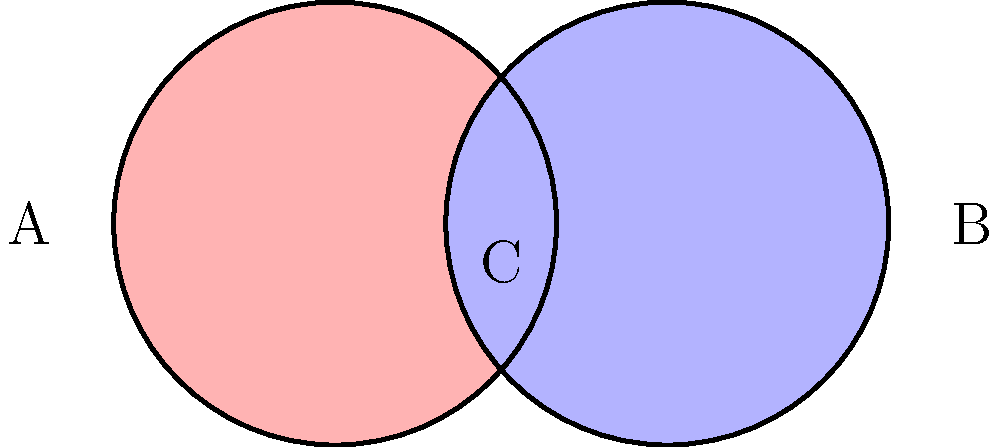In your latest artwork inspired by Juanita Lecaros's use of overlapping forms, you've created a Venn diagram-like composition using two intersecting circles of equal radius. If each circle has a radius of 5 meters, what is the area of the overlapping region (labeled C) in square meters? Round your answer to two decimal places. To find the area of the overlapping region, we need to follow these steps:

1) First, we need to calculate the area of a sector in one circle. The central angle of this sector can be found using the formula:

   $$\theta = 2 \arccos(\frac{d}{2r})$$

   where $d$ is the distance between the centers, and $r$ is the radius.

2) In this case, $d = r = 5$ meters, so:

   $$\theta = 2 \arccos(\frac{5}{2(5)}) = 2 \arccos(0.5) = 2(\frac{\pi}{3}) = \frac{2\pi}{3}$$ radians

3) The area of a sector is given by:

   $$A_{sector} = \frac{1}{2}r^2\theta$$

4) Substituting our values:

   $$A_{sector} = \frac{1}{2}(5^2)(\frac{2\pi}{3}) = \frac{25\pi}{3}$$ sq meters

5) The area of the triangle formed by the radius and chord is:

   $$A_{triangle} = \frac{1}{2}r^2\sin(\theta) = \frac{1}{2}(5^2)\sin(\frac{2\pi}{3}) = \frac{25\sqrt{3}}{4}$$ sq meters

6) The area of the overlapping region is twice the difference between the sector and triangle:

   $$A_{overlap} = 2(A_{sector} - A_{triangle}) = 2(\frac{25\pi}{3} - \frac{25\sqrt{3}}{4})$$

7) Simplifying:

   $$A_{overlap} = \frac{50\pi}{3} - \frac{25\sqrt{3}}{2} \approx 21.46$$ sq meters
Answer: 21.46 sq meters 